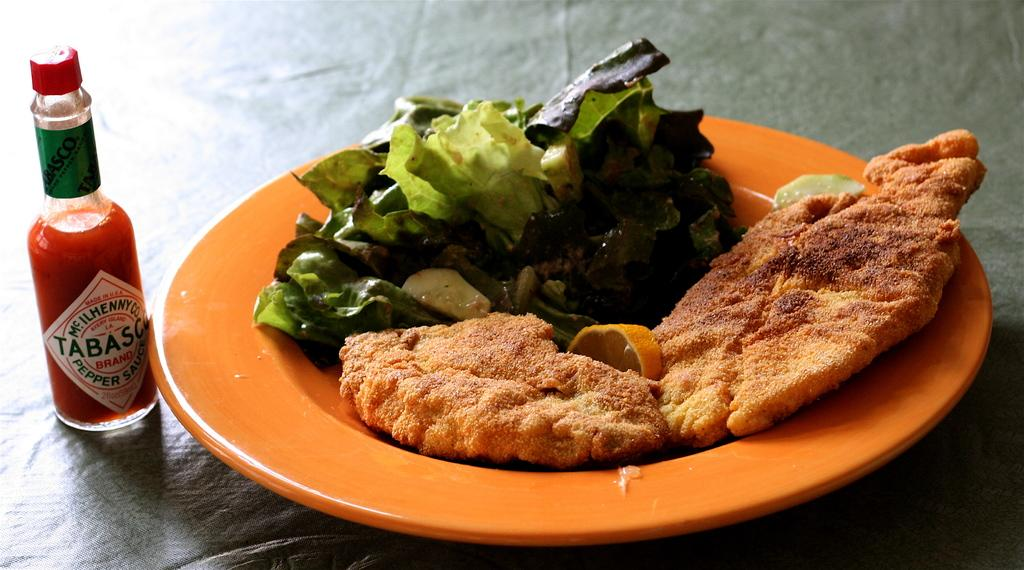What is on the plate that is visible in the image? There is a plate with food items in the image. What else can be seen in the image besides the plate with food? There is a bottle in the image. What type of education can be seen on the sofa in the image? There is no sofa or education present in the image; it only features a plate with food items and a bottle. What sound does the horn make in the image? There is no horn present in the image. 